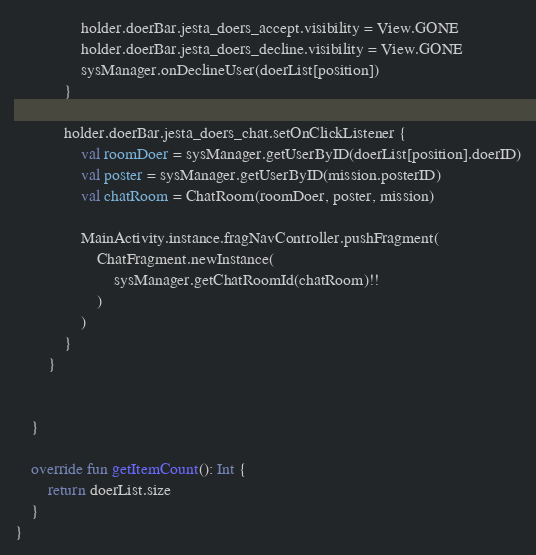<code> <loc_0><loc_0><loc_500><loc_500><_Kotlin_>                holder.doerBar.jesta_doers_accept.visibility = View.GONE
                holder.doerBar.jesta_doers_decline.visibility = View.GONE
                sysManager.onDeclineUser(doerList[position])
            }

            holder.doerBar.jesta_doers_chat.setOnClickListener {
                val roomDoer = sysManager.getUserByID(doerList[position].doerID)
                val poster = sysManager.getUserByID(mission.posterID)
                val chatRoom = ChatRoom(roomDoer, poster, mission)

                MainActivity.instance.fragNavController.pushFragment(
                    ChatFragment.newInstance(
                        sysManager.getChatRoomId(chatRoom)!!
                    )
                )
            }
        }


    }

    override fun getItemCount(): Int {
        return doerList.size
    }
}</code> 